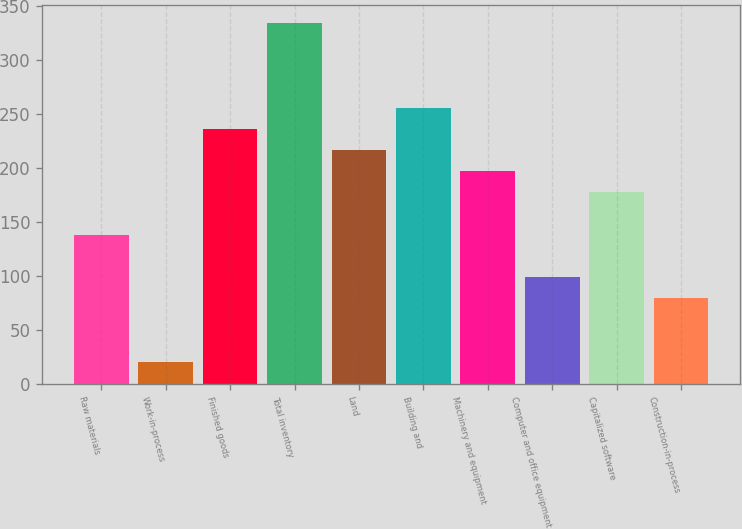<chart> <loc_0><loc_0><loc_500><loc_500><bar_chart><fcel>Raw materials<fcel>Work-in-process<fcel>Finished goods<fcel>Total inventory<fcel>Land<fcel>Building and<fcel>Machinery and equipment<fcel>Computer and office equipment<fcel>Capitalized software<fcel>Construction-in-process<nl><fcel>138.34<fcel>20.62<fcel>236.44<fcel>334.54<fcel>216.82<fcel>256.06<fcel>197.2<fcel>99.1<fcel>177.58<fcel>79.48<nl></chart> 